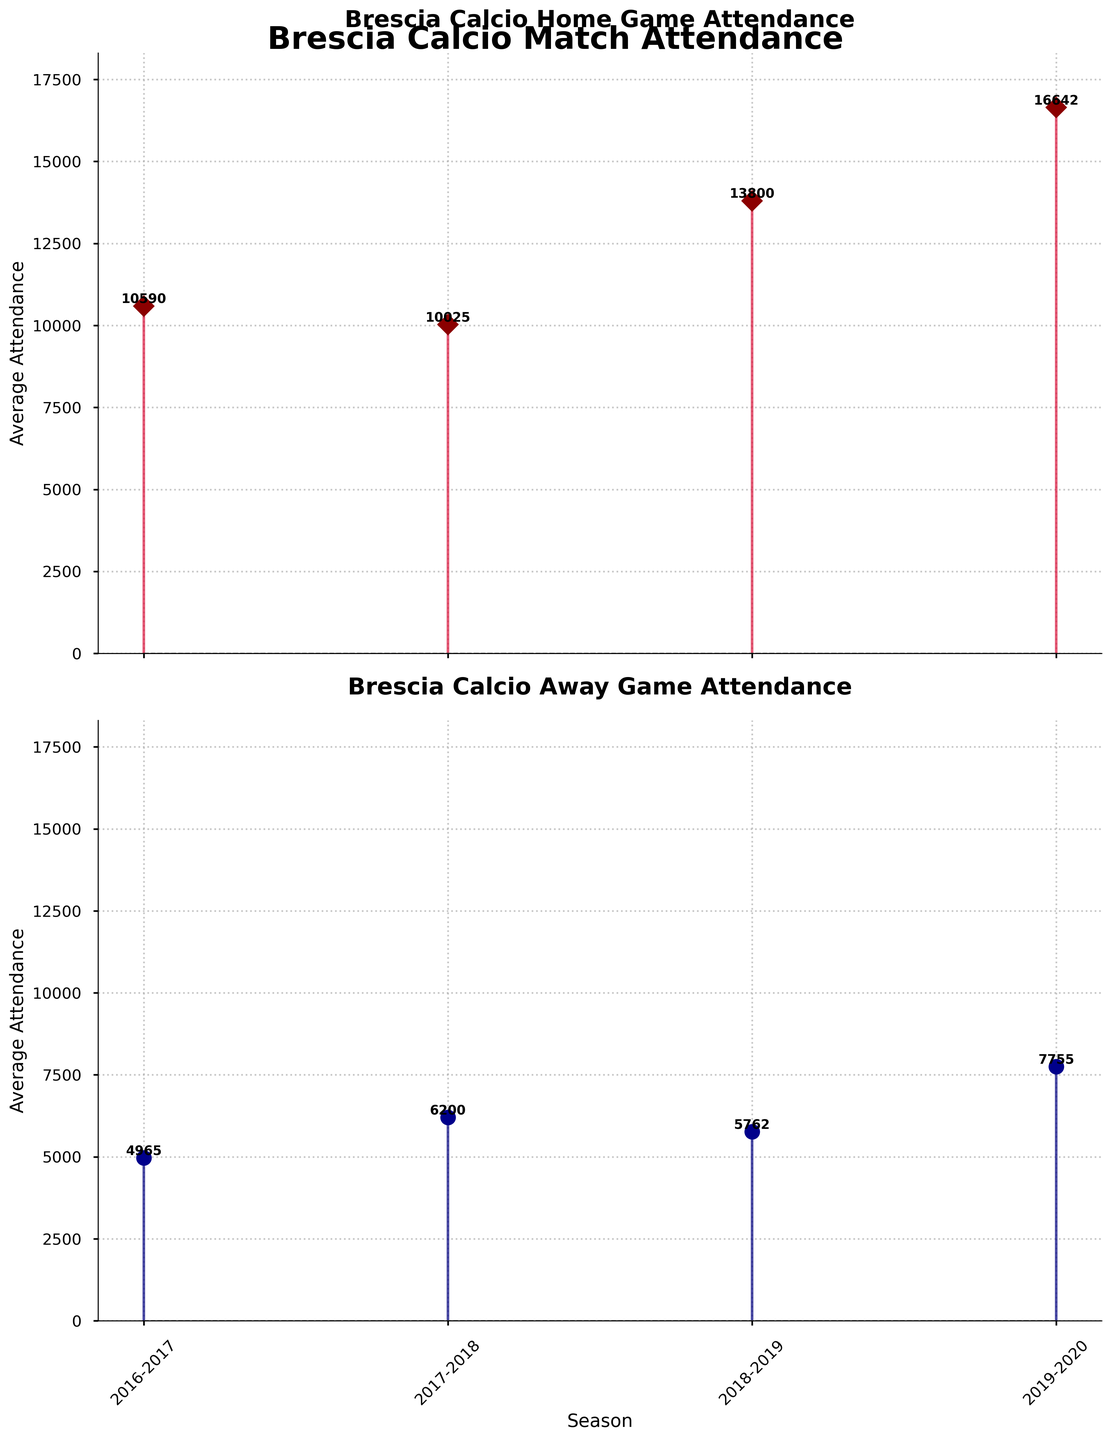What is the title of the first subplot? The title of the first subplot is found at the top of the corresponding section. It reads "Brescia Calcio Home Game Attendance", which identifies the content of this subplot.
Answer: Brescia Calcio Home Game Attendance What is the average home game attendance for the 2019-2020 season? The average home game attendance for the 2019-2020 season can be found by looking at the specific stem point corresponding to the 2019-2020 season in the first subplot. The value is marked near the top of the stem.
Answer: 16643 Which season had the lowest average away game attendance? To determine the season with the lowest average away game attendance, compare the heights of the stem points in the second subplot. The 2016-2017 season has the lowest value, which is visually the smallest stem.
Answer: 2016-2017 How did the home game attendance trend change from the 2016-2017 to the 2019-2020 season? To observe the trend, look at the home game attendance stem points from the 2016-2017 to the 2019-2020 season in the first subplot. Each subsequent season shows increasing values, indicating a rising trend.
Answer: Increasing What is the difference between the home and away attendance for the 2017-2018 season? First, identify the average home game attendance for the 2017-2018 season in the first subplot (10025) and the average away game attendance in the second subplot (6200). Then calculate the difference. 10025 - 6200 = 3825.
Answer: 3825 Which season had a higher variance in attendance values between home and away games? The variance can be determined by visually comparing the gaps between home and away attendance across seasons in both subplots. The 2019-2020 season shows the most visible difference between heights of stems in the two graphs.
Answer: 2019-2020 Does any season have the same average home and away attendance? Check both subplots to see if there are any corresponding points at the same height for any of the seasons. There is no such match in the stems of each subplot, indicating no season with equal average attendance.
Answer: No In which season did home game attendance see the most significant increase from the previous season? By comparing the height of consecutive stems in the first subplot, the most substantial increase is between the 2017-2018 and 2018-2019 seasons.
Answer: 2018-2019 What is the average away attendance for the 2018-2019 season? The value is represented by the specific stem point for the 2018-2019 season in the second subplot and is marked at the top of the stem.
Answer: 5763 